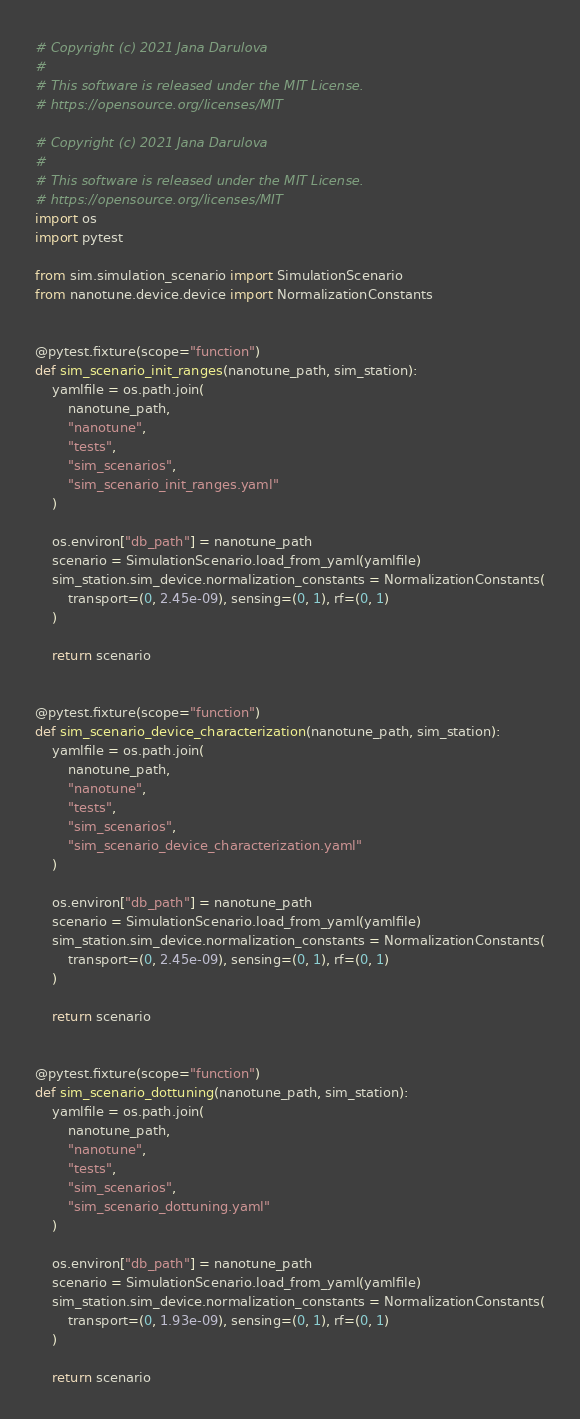Convert code to text. <code><loc_0><loc_0><loc_500><loc_500><_Python_># Copyright (c) 2021 Jana Darulova
#
# This software is released under the MIT License.
# https://opensource.org/licenses/MIT

# Copyright (c) 2021 Jana Darulova
#
# This software is released under the MIT License.
# https://opensource.org/licenses/MIT
import os
import pytest

from sim.simulation_scenario import SimulationScenario
from nanotune.device.device import NormalizationConstants


@pytest.fixture(scope="function")
def sim_scenario_init_ranges(nanotune_path, sim_station):
    yamlfile = os.path.join(
        nanotune_path,
        "nanotune",
        "tests",
        "sim_scenarios",
        "sim_scenario_init_ranges.yaml"
    )

    os.environ["db_path"] = nanotune_path
    scenario = SimulationScenario.load_from_yaml(yamlfile)
    sim_station.sim_device.normalization_constants = NormalizationConstants(
        transport=(0, 2.45e-09), sensing=(0, 1), rf=(0, 1)
    )

    return scenario


@pytest.fixture(scope="function")
def sim_scenario_device_characterization(nanotune_path, sim_station):
    yamlfile = os.path.join(
        nanotune_path,
        "nanotune",
        "tests",
        "sim_scenarios",
        "sim_scenario_device_characterization.yaml"
    )

    os.environ["db_path"] = nanotune_path
    scenario = SimulationScenario.load_from_yaml(yamlfile)
    sim_station.sim_device.normalization_constants = NormalizationConstants(
        transport=(0, 2.45e-09), sensing=(0, 1), rf=(0, 1)
    )

    return scenario


@pytest.fixture(scope="function")
def sim_scenario_dottuning(nanotune_path, sim_station):
    yamlfile = os.path.join(
        nanotune_path,
        "nanotune",
        "tests",
        "sim_scenarios",
        "sim_scenario_dottuning.yaml"
    )

    os.environ["db_path"] = nanotune_path
    scenario = SimulationScenario.load_from_yaml(yamlfile)
    sim_station.sim_device.normalization_constants = NormalizationConstants(
        transport=(0, 1.93e-09), sensing=(0, 1), rf=(0, 1)
    )

    return scenario
</code> 